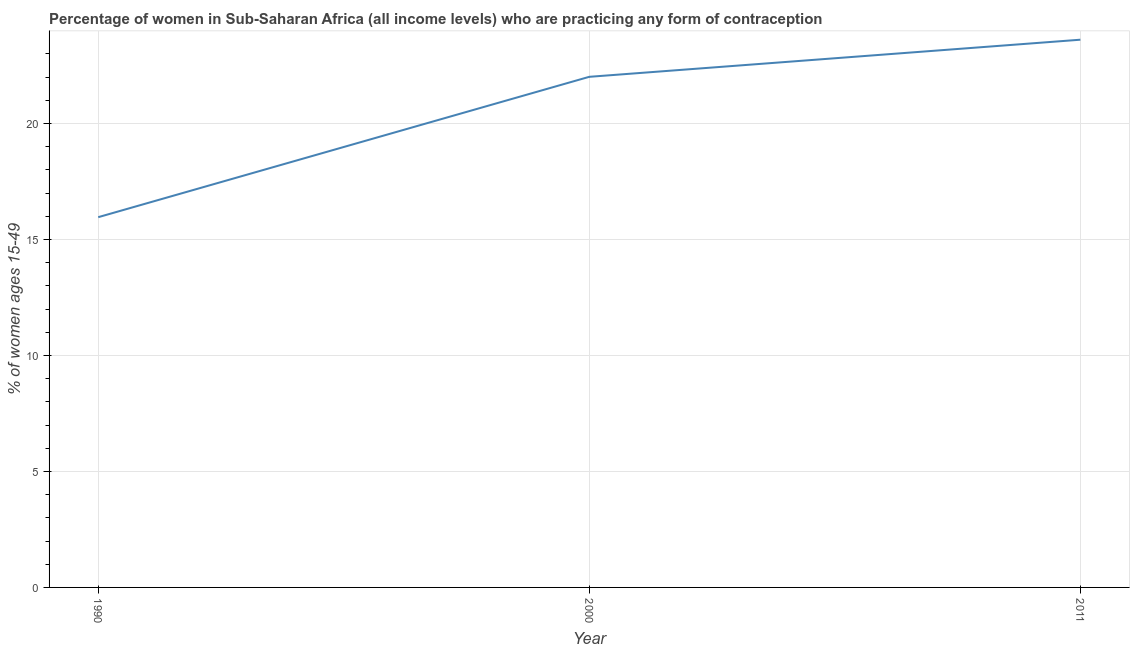What is the contraceptive prevalence in 2011?
Your answer should be very brief. 23.61. Across all years, what is the maximum contraceptive prevalence?
Make the answer very short. 23.61. Across all years, what is the minimum contraceptive prevalence?
Your response must be concise. 15.96. What is the sum of the contraceptive prevalence?
Ensure brevity in your answer.  61.59. What is the difference between the contraceptive prevalence in 2000 and 2011?
Your response must be concise. -1.6. What is the average contraceptive prevalence per year?
Give a very brief answer. 20.53. What is the median contraceptive prevalence?
Provide a short and direct response. 22.01. Do a majority of the years between 1990 and 2011 (inclusive) have contraceptive prevalence greater than 2 %?
Offer a terse response. Yes. What is the ratio of the contraceptive prevalence in 1990 to that in 2011?
Your response must be concise. 0.68. Is the contraceptive prevalence in 1990 less than that in 2000?
Offer a terse response. Yes. What is the difference between the highest and the second highest contraceptive prevalence?
Provide a short and direct response. 1.6. Is the sum of the contraceptive prevalence in 2000 and 2011 greater than the maximum contraceptive prevalence across all years?
Offer a terse response. Yes. What is the difference between the highest and the lowest contraceptive prevalence?
Your answer should be very brief. 7.65. In how many years, is the contraceptive prevalence greater than the average contraceptive prevalence taken over all years?
Give a very brief answer. 2. Does the contraceptive prevalence monotonically increase over the years?
Provide a short and direct response. Yes. What is the difference between two consecutive major ticks on the Y-axis?
Provide a succinct answer. 5. Are the values on the major ticks of Y-axis written in scientific E-notation?
Make the answer very short. No. Does the graph contain any zero values?
Give a very brief answer. No. Does the graph contain grids?
Your answer should be very brief. Yes. What is the title of the graph?
Offer a terse response. Percentage of women in Sub-Saharan Africa (all income levels) who are practicing any form of contraception. What is the label or title of the Y-axis?
Your answer should be compact. % of women ages 15-49. What is the % of women ages 15-49 of 1990?
Ensure brevity in your answer.  15.96. What is the % of women ages 15-49 in 2000?
Your answer should be compact. 22.01. What is the % of women ages 15-49 of 2011?
Your answer should be very brief. 23.61. What is the difference between the % of women ages 15-49 in 1990 and 2000?
Offer a very short reply. -6.05. What is the difference between the % of women ages 15-49 in 1990 and 2011?
Provide a short and direct response. -7.65. What is the difference between the % of women ages 15-49 in 2000 and 2011?
Provide a succinct answer. -1.6. What is the ratio of the % of women ages 15-49 in 1990 to that in 2000?
Ensure brevity in your answer.  0.72. What is the ratio of the % of women ages 15-49 in 1990 to that in 2011?
Offer a very short reply. 0.68. What is the ratio of the % of women ages 15-49 in 2000 to that in 2011?
Provide a succinct answer. 0.93. 